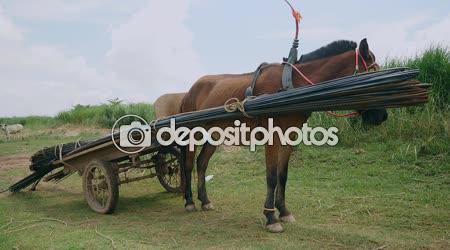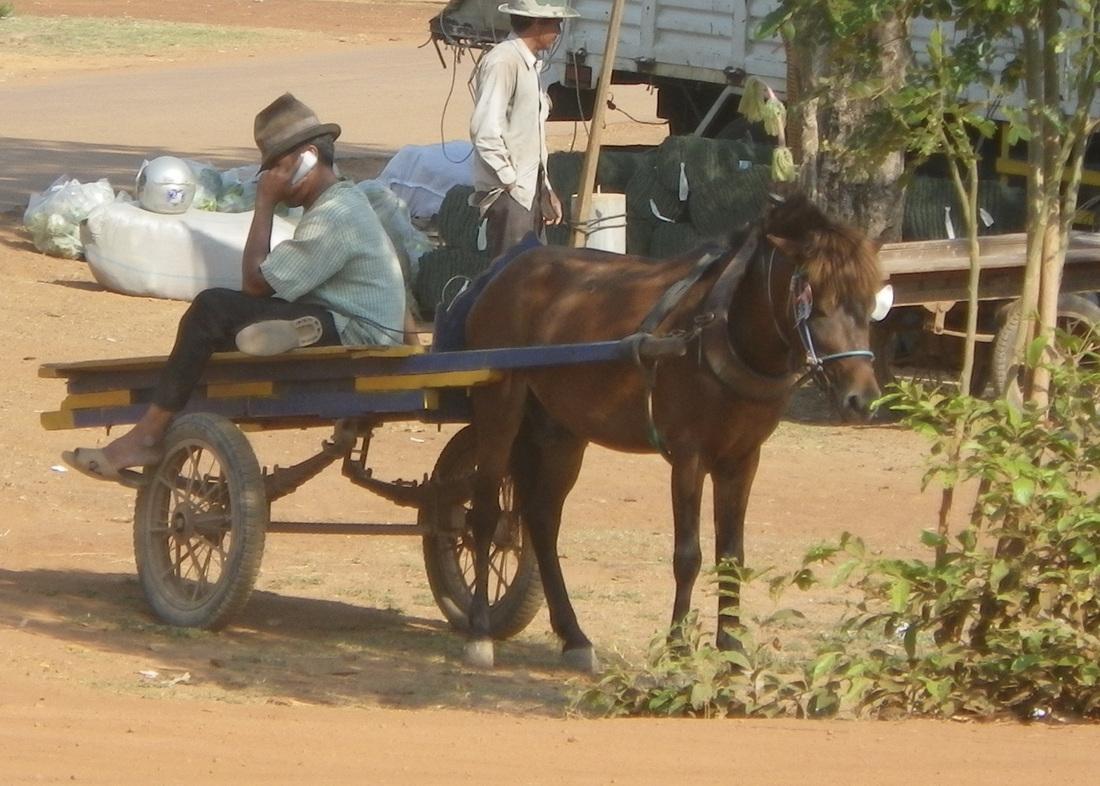The first image is the image on the left, the second image is the image on the right. Evaluate the accuracy of this statement regarding the images: "The wagon in the image on the right is not attached to a horse.". Is it true? Answer yes or no. No. The first image is the image on the left, the second image is the image on the right. Analyze the images presented: Is the assertion "An image shows two side-by-side horses pulling some type of wheeled thing steered by a man." valid? Answer yes or no. No. 